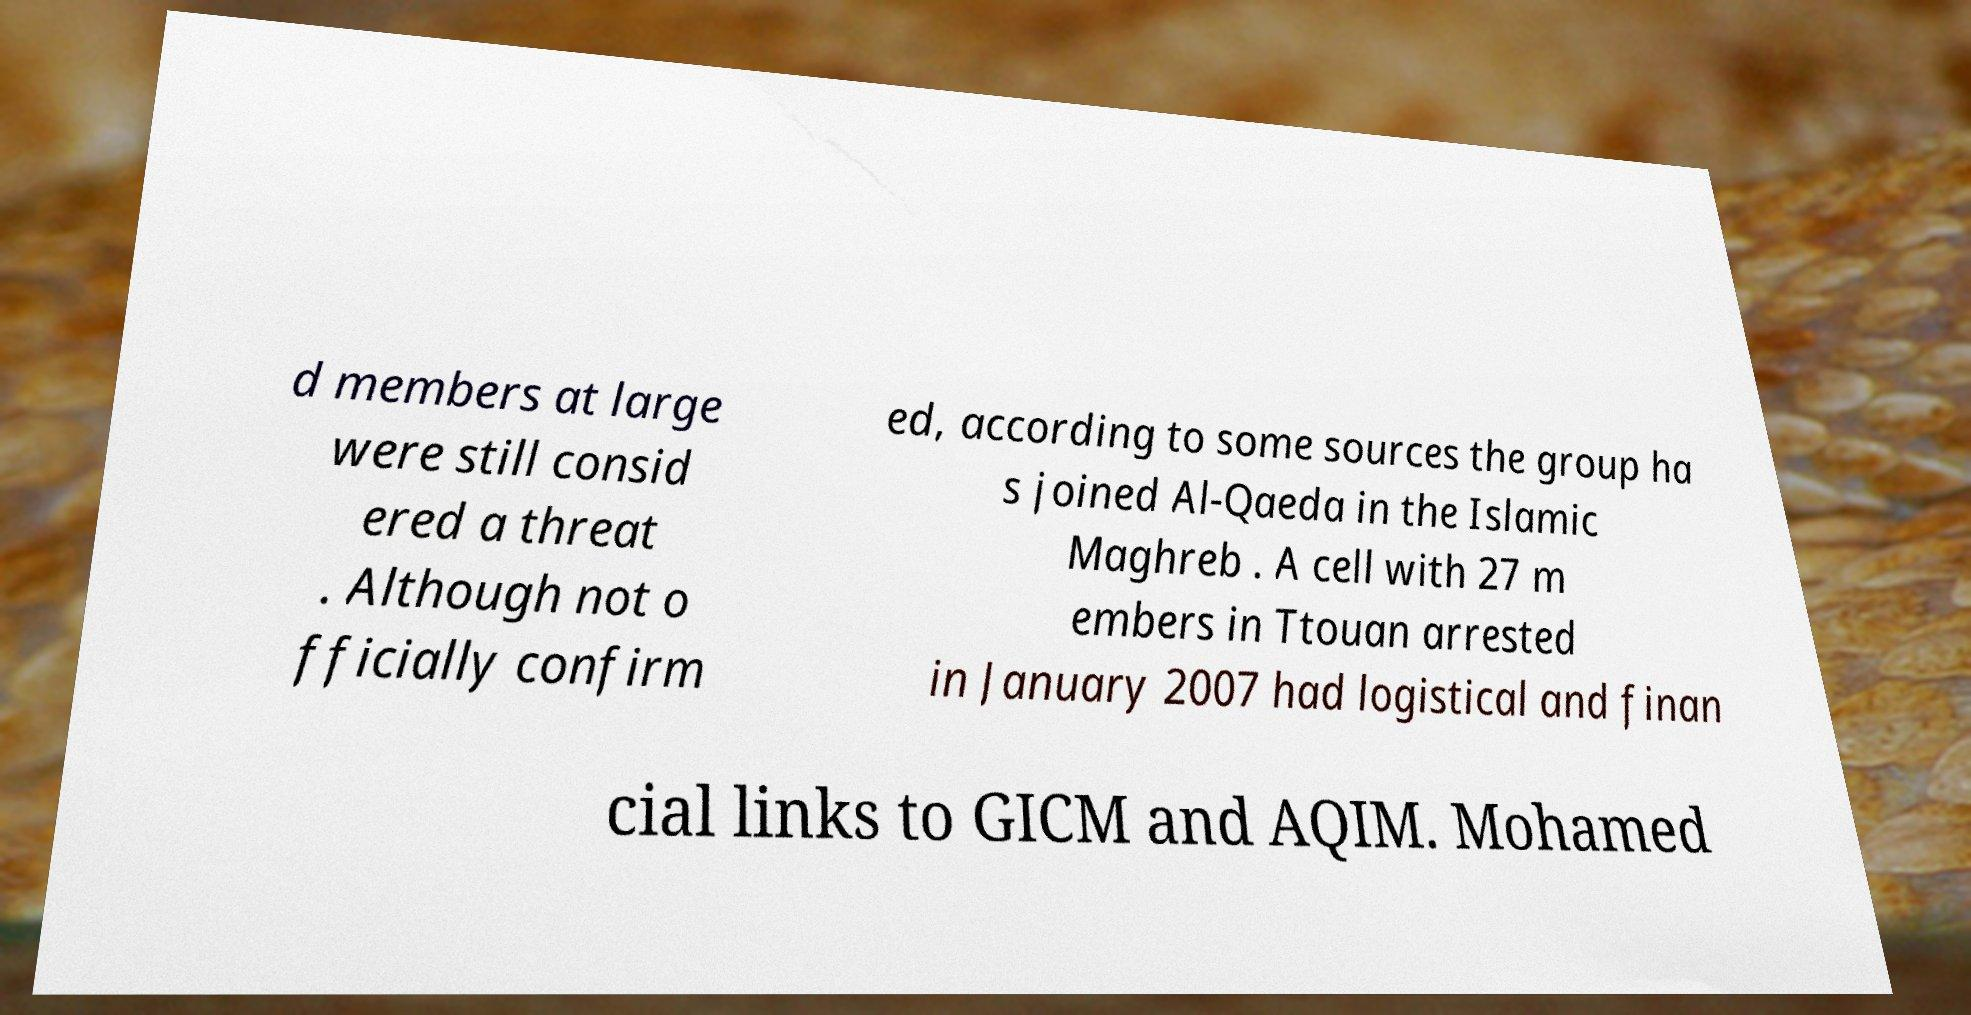Could you extract and type out the text from this image? d members at large were still consid ered a threat . Although not o fficially confirm ed, according to some sources the group ha s joined Al-Qaeda in the Islamic Maghreb . A cell with 27 m embers in Ttouan arrested in January 2007 had logistical and finan cial links to GICM and AQIM. Mohamed 